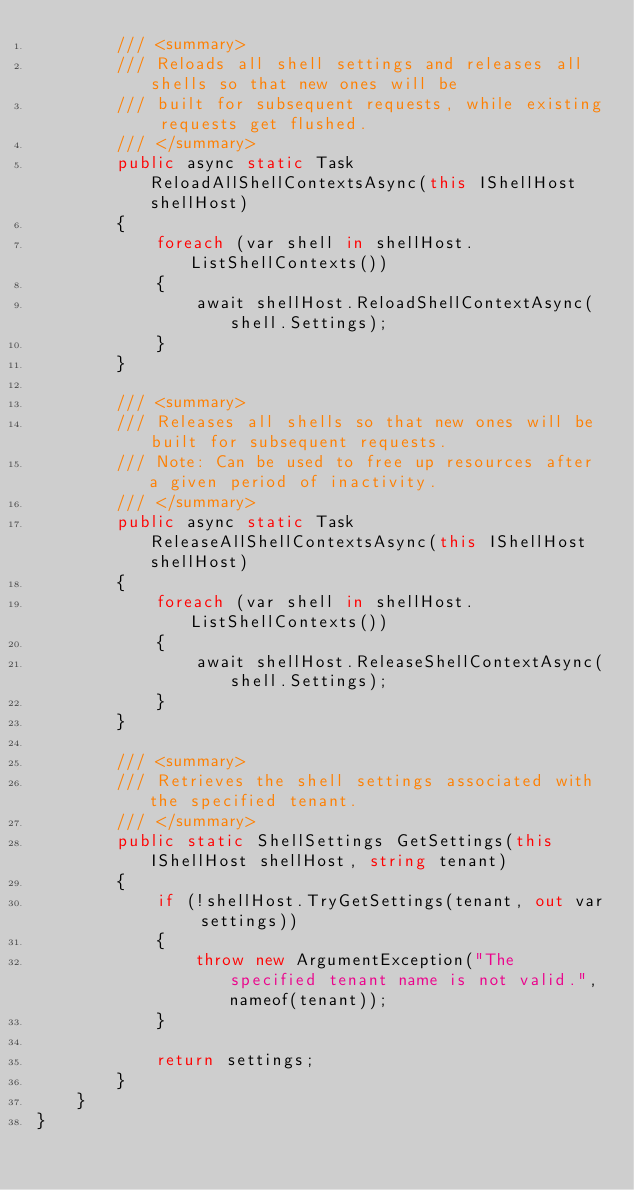<code> <loc_0><loc_0><loc_500><loc_500><_C#_>        /// <summary>
        /// Reloads all shell settings and releases all shells so that new ones will be
        /// built for subsequent requests, while existing requests get flushed.
        /// </summary>
        public async static Task ReloadAllShellContextsAsync(this IShellHost shellHost)
        {
            foreach (var shell in shellHost.ListShellContexts())
            {
                await shellHost.ReloadShellContextAsync(shell.Settings);
            }
        }

        /// <summary>
        /// Releases all shells so that new ones will be built for subsequent requests.
        /// Note: Can be used to free up resources after a given period of inactivity.
        /// </summary>
        public async static Task ReleaseAllShellContextsAsync(this IShellHost shellHost)
        {
            foreach (var shell in shellHost.ListShellContexts())
            {
                await shellHost.ReleaseShellContextAsync(shell.Settings);
            }
        }

        /// <summary>
        /// Retrieves the shell settings associated with the specified tenant.
        /// </summary>
        public static ShellSettings GetSettings(this IShellHost shellHost, string tenant)
        {
            if (!shellHost.TryGetSettings(tenant, out var settings))
            {
                throw new ArgumentException("The specified tenant name is not valid.", nameof(tenant));
            }

            return settings;
        }
    }
}
</code> 